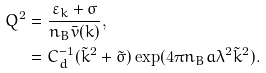<formula> <loc_0><loc_0><loc_500><loc_500>Q ^ { 2 } & = \frac { \varepsilon _ { k } + \sigma } { n _ { B } \bar { v } ( k ) } , \\ & = C _ { d } ^ { - 1 } ( \tilde { k } ^ { 2 } + \tilde { \sigma } ) \exp ( 4 \pi n _ { B } a \lambda ^ { 2 } \tilde { k } ^ { 2 } ) .</formula> 